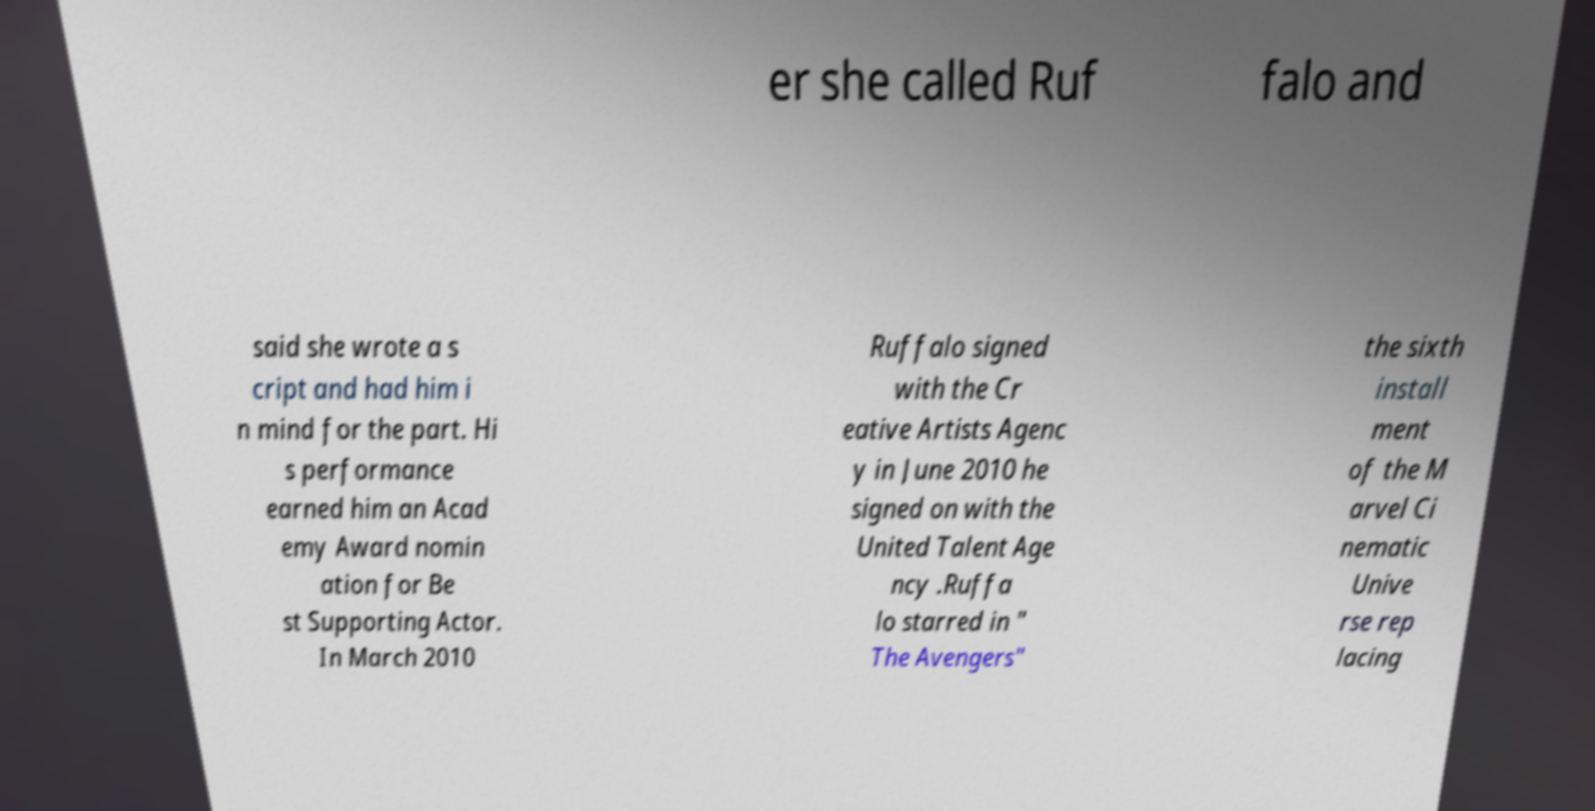Could you extract and type out the text from this image? er she called Ruf falo and said she wrote a s cript and had him i n mind for the part. Hi s performance earned him an Acad emy Award nomin ation for Be st Supporting Actor. In March 2010 Ruffalo signed with the Cr eative Artists Agenc y in June 2010 he signed on with the United Talent Age ncy .Ruffa lo starred in " The Avengers" the sixth install ment of the M arvel Ci nematic Unive rse rep lacing 